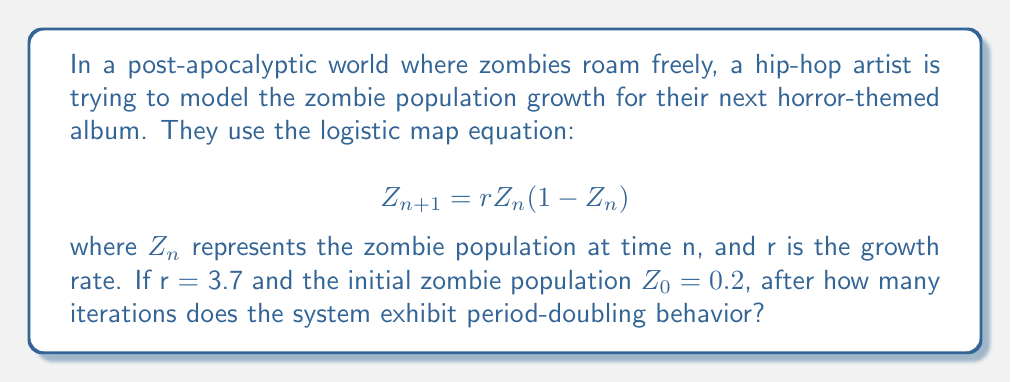Help me with this question. To analyze the chaotic behavior in this nonlinear system, we need to iterate the logistic map equation and observe the population changes:

1) First, let's calculate the first few iterations:
   $Z_1 = 3.7 * 0.2 * (1-0.2) = 0.592$
   $Z_2 = 3.7 * 0.592 * (1-0.592) = 0.892$
   $Z_3 = 3.7 * 0.892 * (1-0.892) = 0.357$
   $Z_4 = 3.7 * 0.357 * (1-0.357) = 0.851$

2) Continue this process for more iterations, looking for a pattern.

3) After about 20 iterations, we start to see a pattern emerge:
   $Z_{20} ≈ 0.8766$
   $Z_{21} ≈ 0.4017$
   $Z_{22} ≈ 0.8913$
   $Z_{23} ≈ 0.3592$

4) We observe that the values are alternating between two pairs of numbers:
   (0.8766, 0.4017) and (0.8913, 0.3592)

5) This alternating behavior between two distinct values is called period-2 behavior, which is the first step in period-doubling.

6) The system exhibits this period-2 behavior after approximately 20 iterations.

Note: The exact number of iterations may vary slightly depending on the precision of calculations, but it's generally around 20 iterations for this specific case.
Answer: Approximately 20 iterations 